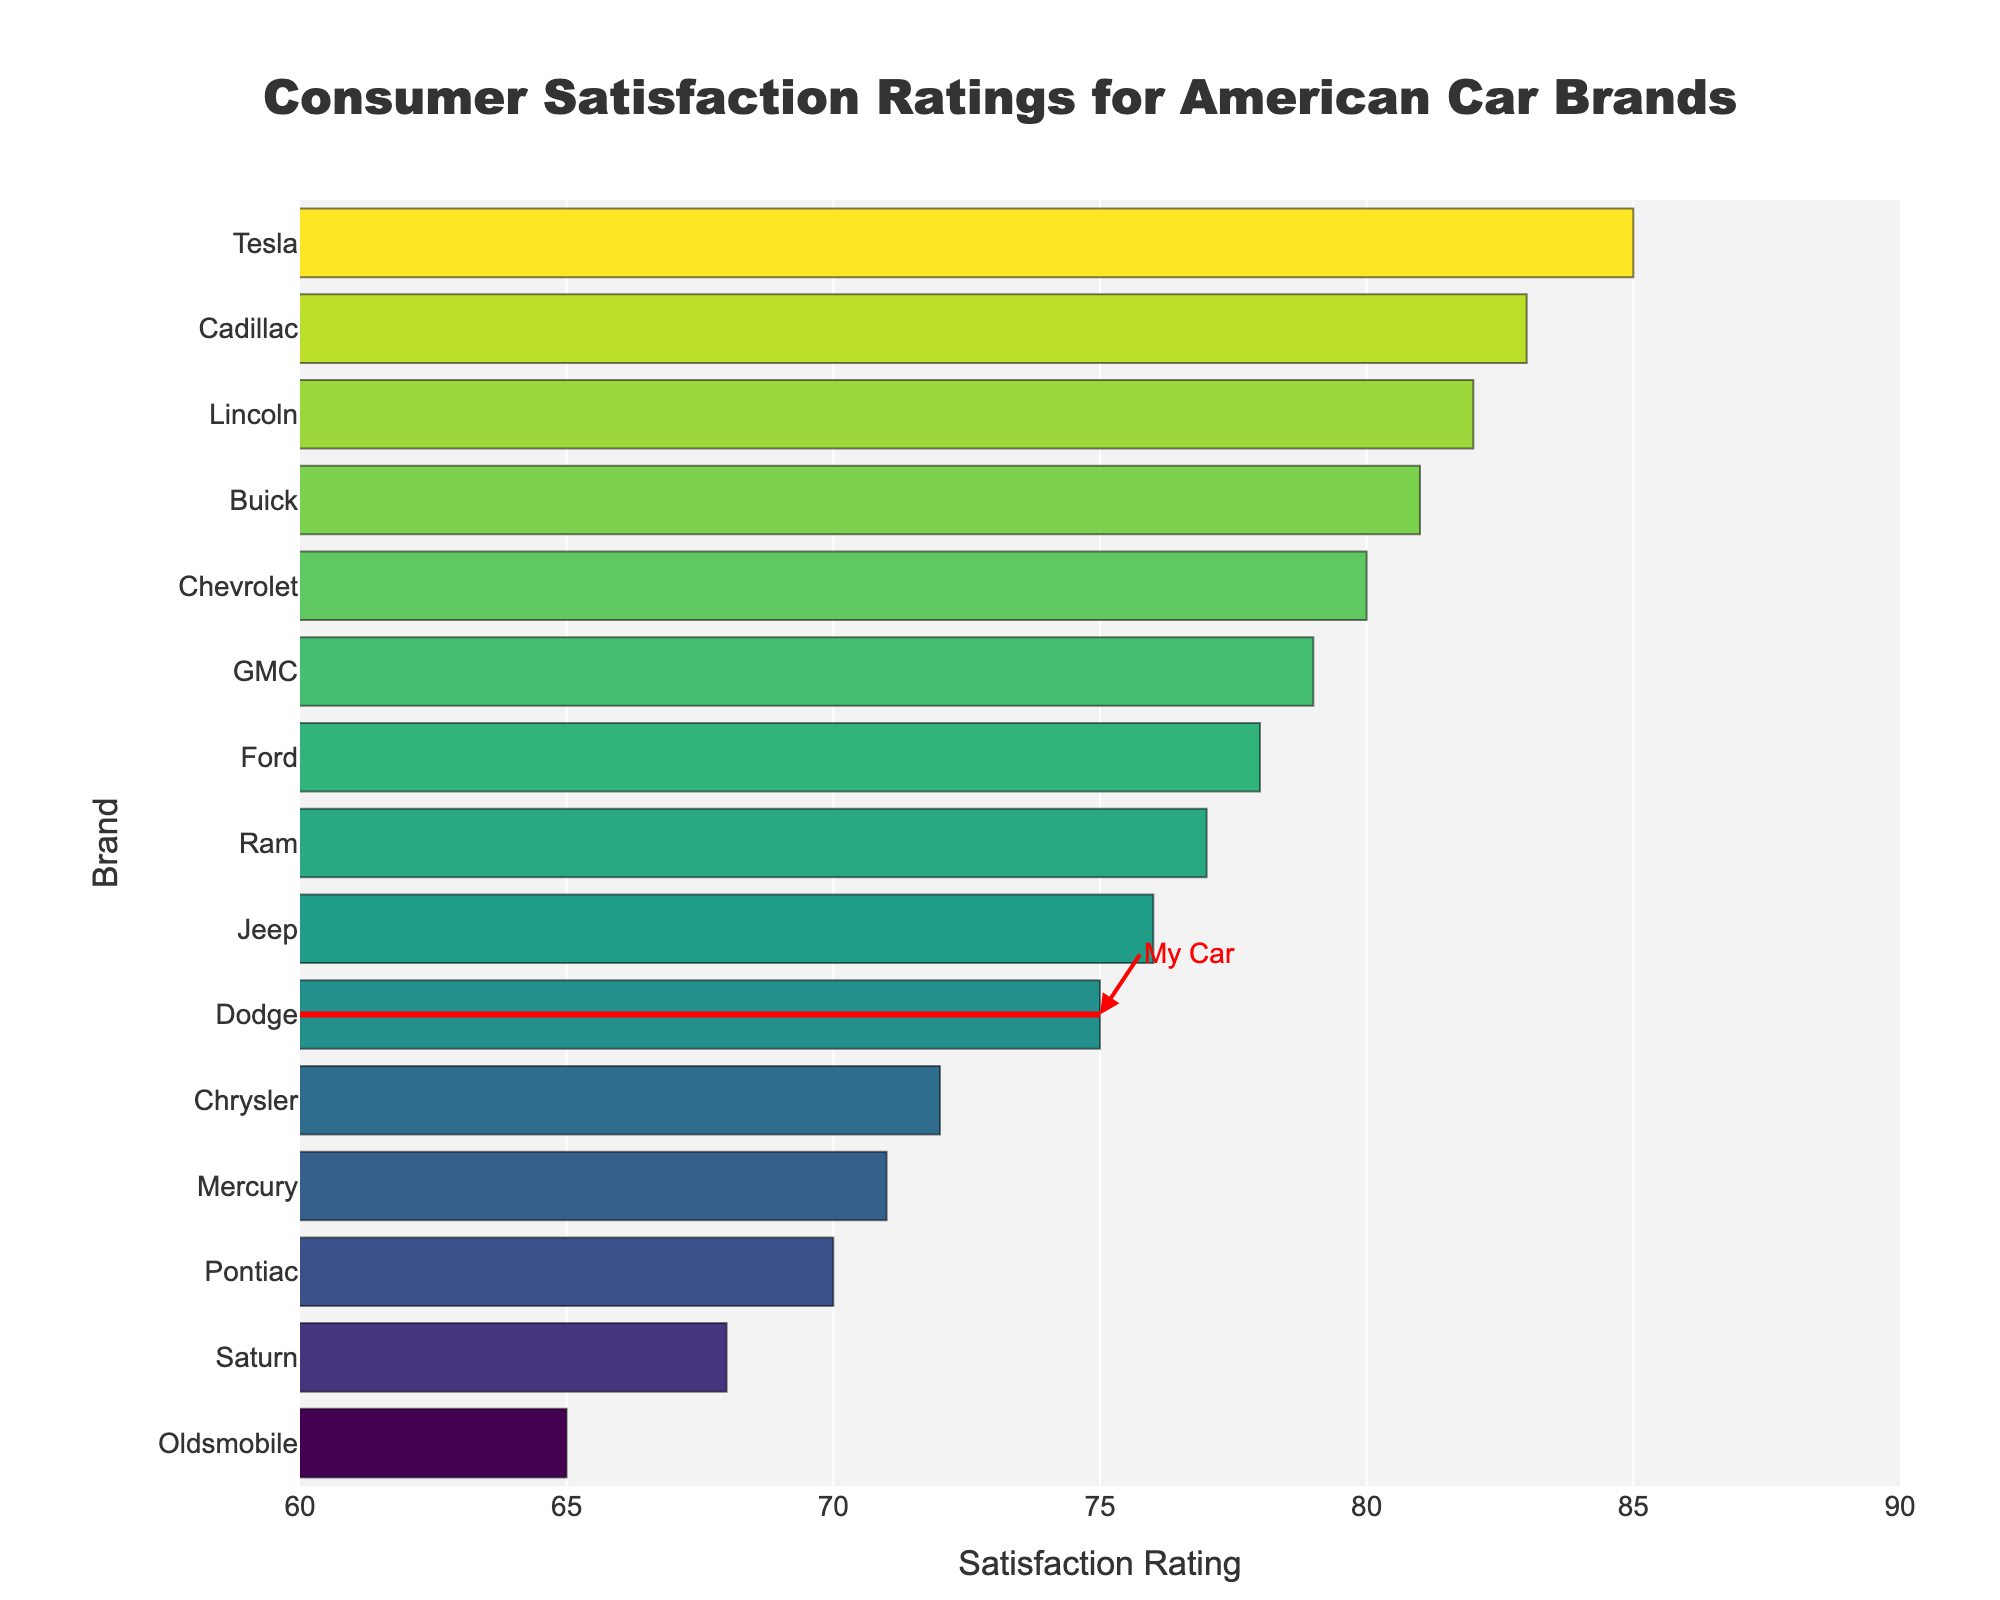Which brand has the highest consumer satisfaction rating? The figure shows the consumer satisfaction ratings for each car brand arranged in ascending order, with Tesla at the top of the chart with the highest rating.
Answer: Tesla What is the satisfaction rating of Dodge? Dodge is marked with a special annotation in the figure. The bar for Dodge highlights its rating on the x-axis.
Answer: 75 Which brand has the lowest consumer satisfaction rating? The figure shows the satisfaction ratings in ascending order, with Oldsmobile at the bottom of the chart.
Answer: Oldsmobile What is the difference in satisfaction rating between Tesla and Oldsmobile? Tesla has a rating of 85 and Oldsmobile has a rating of 65, so the difference is 85 - 65.
Answer: 20 Which two brands have ratings closest to each other, and what are their ratings? By observing the figure, Chevrolet and GMC have very close ratings with Chevrolet at 80 and GMC at 79.
Answer: Chevrolet - 80, GMC - 79 Is Dodge's satisfaction rating above or below the average rating of all brands? First, calculate the average rating of all brands: (78+80+75+72+76+81+83+79+77+82+85+70+68+65+71) / 15 = 75.53. Dodge's rating is 75, which is below the average.
Answer: Below What is the average satisfaction rating of brands with a rating above 80? The brands with a rating above 80 are Buick (81), Cadillac (83), Lincoln (82), and Tesla (85). The average is (81+83+82+85) / 4 = 82.75.
Answer: 82.75 Which brand's satisfaction rating is closest to 80, and what is its rating? By examining the figure, Chevrolet has a satisfaction rating of 80, which matches exactly.
Answer: Chevrolet - 80 What is the sum of the satisfaction ratings of Buick and GMC? Buick has a rating of 81, and GMC has a rating of 79; summing them gives 81 + 79.
Answer: 160 How many brands have a satisfaction rating below 70, and which are they? The bar chart shows Saturn (68), Oldsmobile (65), and Mercury (71); thus, two brands have ratings below 70.
Answer: Saturn, Oldsmobile 